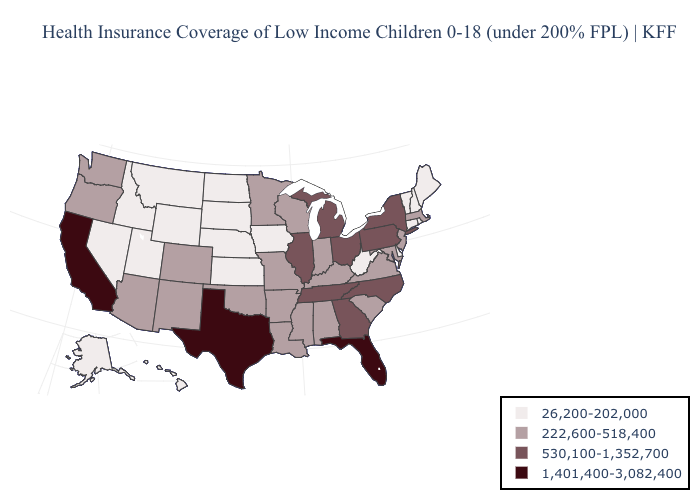What is the value of New Jersey?
Answer briefly. 222,600-518,400. Name the states that have a value in the range 530,100-1,352,700?
Answer briefly. Georgia, Illinois, Michigan, New York, North Carolina, Ohio, Pennsylvania, Tennessee. Name the states that have a value in the range 530,100-1,352,700?
Short answer required. Georgia, Illinois, Michigan, New York, North Carolina, Ohio, Pennsylvania, Tennessee. Name the states that have a value in the range 26,200-202,000?
Concise answer only. Alaska, Connecticut, Delaware, Hawaii, Idaho, Iowa, Kansas, Maine, Montana, Nebraska, Nevada, New Hampshire, North Dakota, Rhode Island, South Dakota, Utah, Vermont, West Virginia, Wyoming. Name the states that have a value in the range 26,200-202,000?
Answer briefly. Alaska, Connecticut, Delaware, Hawaii, Idaho, Iowa, Kansas, Maine, Montana, Nebraska, Nevada, New Hampshire, North Dakota, Rhode Island, South Dakota, Utah, Vermont, West Virginia, Wyoming. Does Nevada have the highest value in the West?
Answer briefly. No. What is the lowest value in the MidWest?
Short answer required. 26,200-202,000. Is the legend a continuous bar?
Keep it brief. No. Does New York have the same value as Ohio?
Short answer required. Yes. What is the value of Alabama?
Be succinct. 222,600-518,400. How many symbols are there in the legend?
Short answer required. 4. Does South Dakota have the lowest value in the USA?
Be succinct. Yes. What is the value of Mississippi?
Answer briefly. 222,600-518,400. What is the value of South Dakota?
Answer briefly. 26,200-202,000. Which states have the highest value in the USA?
Quick response, please. California, Florida, Texas. 